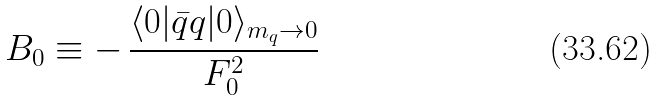Convert formula to latex. <formula><loc_0><loc_0><loc_500><loc_500>B _ { 0 } \equiv - \, \frac { \langle 0 | \bar { q } q | 0 \rangle _ { m _ { q } \to 0 } } { F _ { 0 } ^ { 2 } }</formula> 